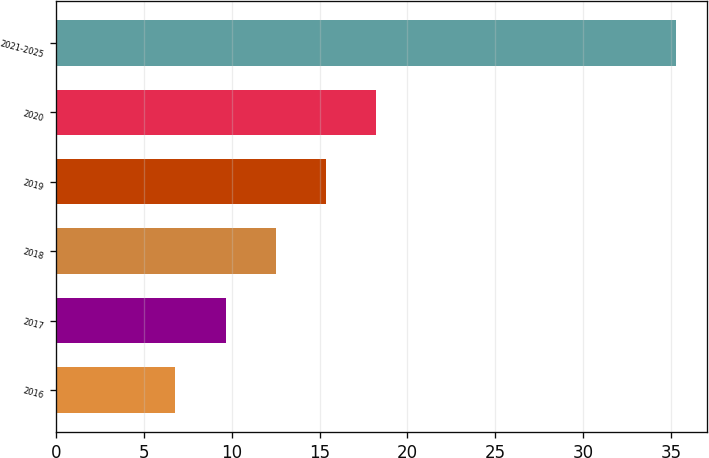Convert chart to OTSL. <chart><loc_0><loc_0><loc_500><loc_500><bar_chart><fcel>2016<fcel>2017<fcel>2018<fcel>2019<fcel>2020<fcel>2021-2025<nl><fcel>6.8<fcel>9.65<fcel>12.5<fcel>15.35<fcel>18.2<fcel>35.3<nl></chart> 